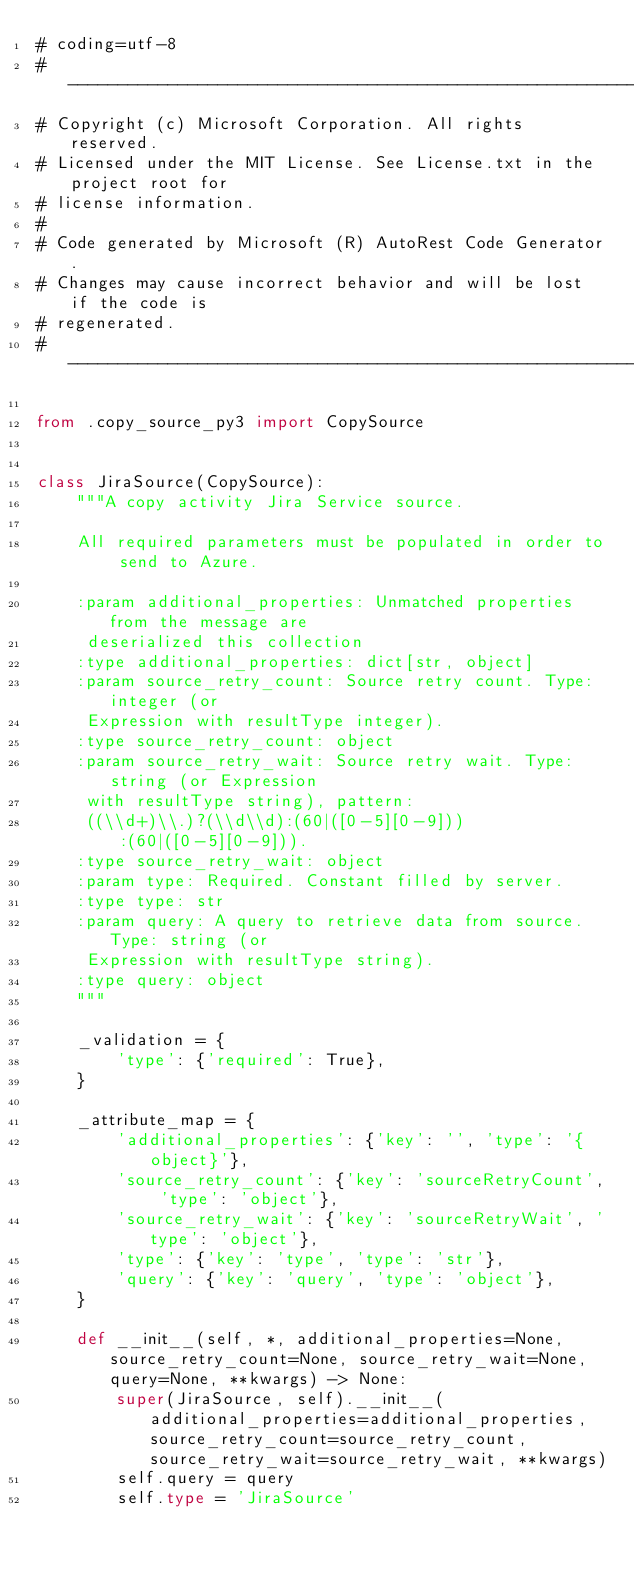Convert code to text. <code><loc_0><loc_0><loc_500><loc_500><_Python_># coding=utf-8
# --------------------------------------------------------------------------
# Copyright (c) Microsoft Corporation. All rights reserved.
# Licensed under the MIT License. See License.txt in the project root for
# license information.
#
# Code generated by Microsoft (R) AutoRest Code Generator.
# Changes may cause incorrect behavior and will be lost if the code is
# regenerated.
# --------------------------------------------------------------------------

from .copy_source_py3 import CopySource


class JiraSource(CopySource):
    """A copy activity Jira Service source.

    All required parameters must be populated in order to send to Azure.

    :param additional_properties: Unmatched properties from the message are
     deserialized this collection
    :type additional_properties: dict[str, object]
    :param source_retry_count: Source retry count. Type: integer (or
     Expression with resultType integer).
    :type source_retry_count: object
    :param source_retry_wait: Source retry wait. Type: string (or Expression
     with resultType string), pattern:
     ((\\d+)\\.)?(\\d\\d):(60|([0-5][0-9])):(60|([0-5][0-9])).
    :type source_retry_wait: object
    :param type: Required. Constant filled by server.
    :type type: str
    :param query: A query to retrieve data from source. Type: string (or
     Expression with resultType string).
    :type query: object
    """

    _validation = {
        'type': {'required': True},
    }

    _attribute_map = {
        'additional_properties': {'key': '', 'type': '{object}'},
        'source_retry_count': {'key': 'sourceRetryCount', 'type': 'object'},
        'source_retry_wait': {'key': 'sourceRetryWait', 'type': 'object'},
        'type': {'key': 'type', 'type': 'str'},
        'query': {'key': 'query', 'type': 'object'},
    }

    def __init__(self, *, additional_properties=None, source_retry_count=None, source_retry_wait=None, query=None, **kwargs) -> None:
        super(JiraSource, self).__init__(additional_properties=additional_properties, source_retry_count=source_retry_count, source_retry_wait=source_retry_wait, **kwargs)
        self.query = query
        self.type = 'JiraSource'
</code> 